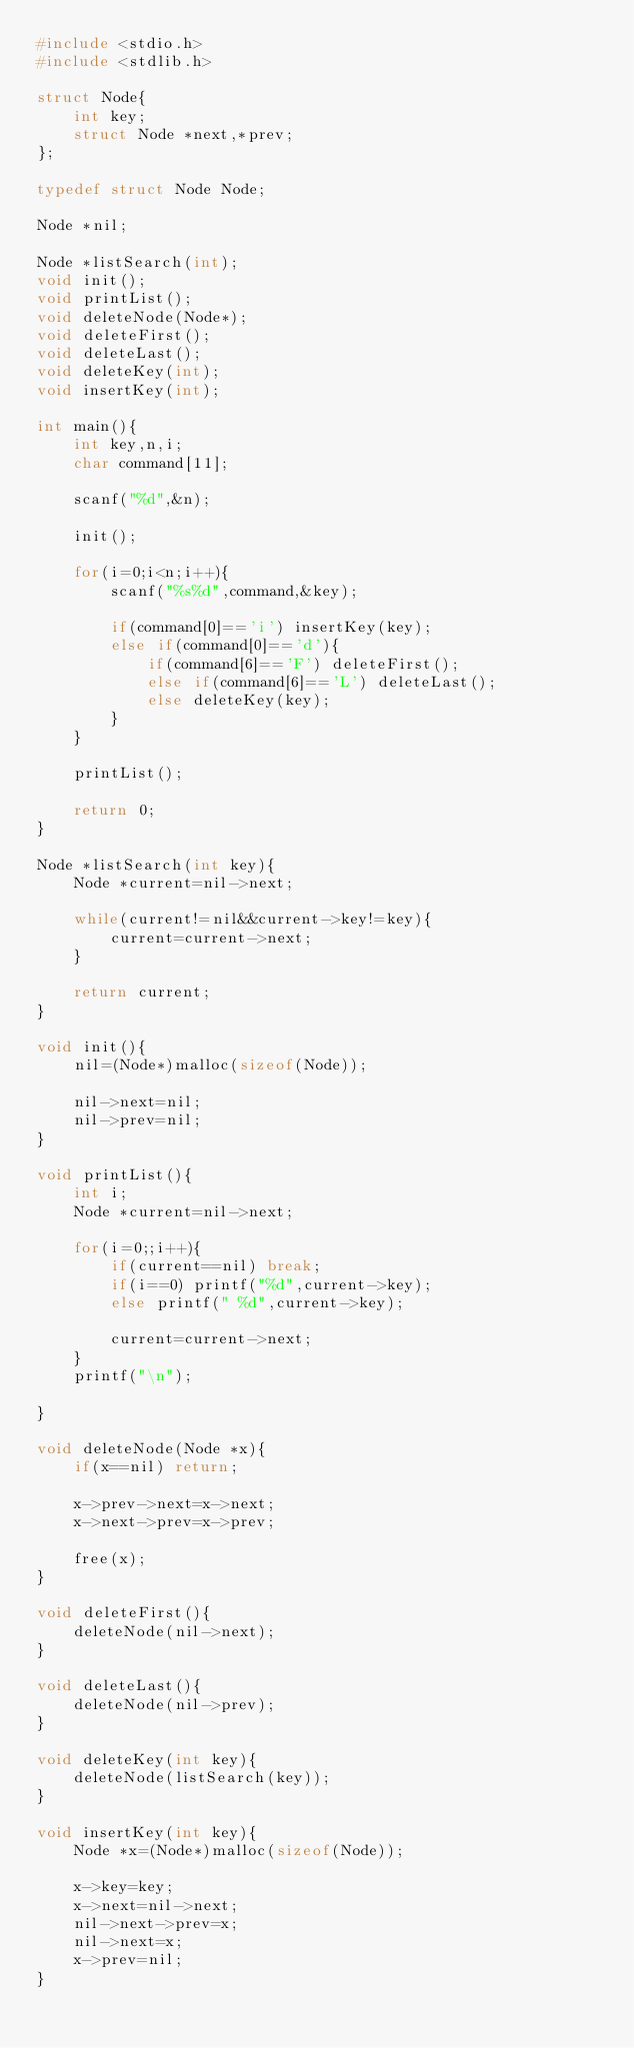<code> <loc_0><loc_0><loc_500><loc_500><_C_>#include <stdio.h>
#include <stdlib.h>

struct Node{
    int key;
    struct Node *next,*prev;
};

typedef struct Node Node;

Node *nil;

Node *listSearch(int);
void init();
void printList();
void deleteNode(Node*);
void deleteFirst();
void deleteLast();
void deleteKey(int);
void insertKey(int);

int main(){
    int key,n,i;
    char command[11];

    scanf("%d",&n);

    init();

    for(i=0;i<n;i++){
        scanf("%s%d",command,&key);

        if(command[0]=='i') insertKey(key);
        else if(command[0]=='d'){
            if(command[6]=='F') deleteFirst();
            else if(command[6]=='L') deleteLast();
            else deleteKey(key);
        }
    }

    printList();

    return 0;
}

Node *listSearch(int key){
    Node *current=nil->next;

    while(current!=nil&&current->key!=key){
        current=current->next;
    }

    return current;
}

void init(){
    nil=(Node*)malloc(sizeof(Node));

    nil->next=nil;
    nil->prev=nil;
}

void printList(){
    int i;
    Node *current=nil->next;

    for(i=0;;i++){
        if(current==nil) break;
        if(i==0) printf("%d",current->key);
        else printf(" %d",current->key);
     
        current=current->next;
    }
    printf("\n");

}

void deleteNode(Node *x){
    if(x==nil) return;

    x->prev->next=x->next;
    x->next->prev=x->prev;

    free(x);
}

void deleteFirst(){
    deleteNode(nil->next);
}

void deleteLast(){
    deleteNode(nil->prev);
}

void deleteKey(int key){
    deleteNode(listSearch(key));
}

void insertKey(int key){
    Node *x=(Node*)malloc(sizeof(Node));

    x->key=key;
    x->next=nil->next;
    nil->next->prev=x;
    nil->next=x;
    x->prev=nil;
}
</code> 